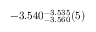Convert formula to latex. <formula><loc_0><loc_0><loc_500><loc_500>- 3 . 5 4 0 _ { - 3 . 5 6 0 } ^ { - 3 . 5 3 5 } ( 5 )</formula> 